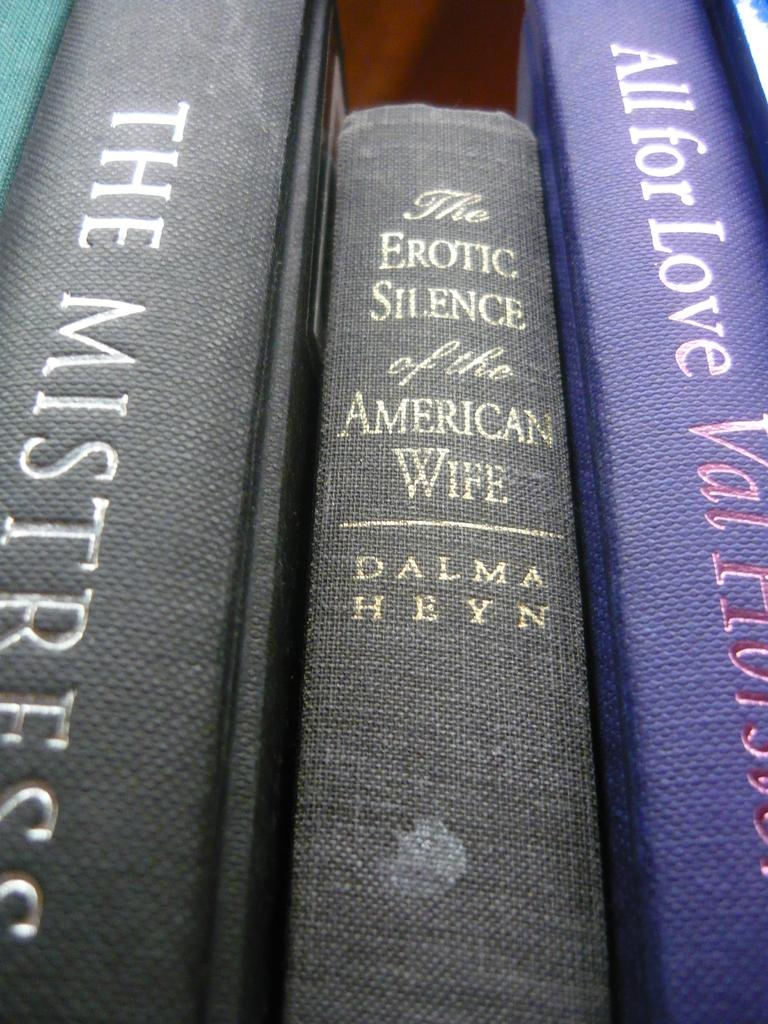<image>
Relay a brief, clear account of the picture shown. An up close view of a stack of books, the middle book is titled The Erotic Silence of the American Wife. 